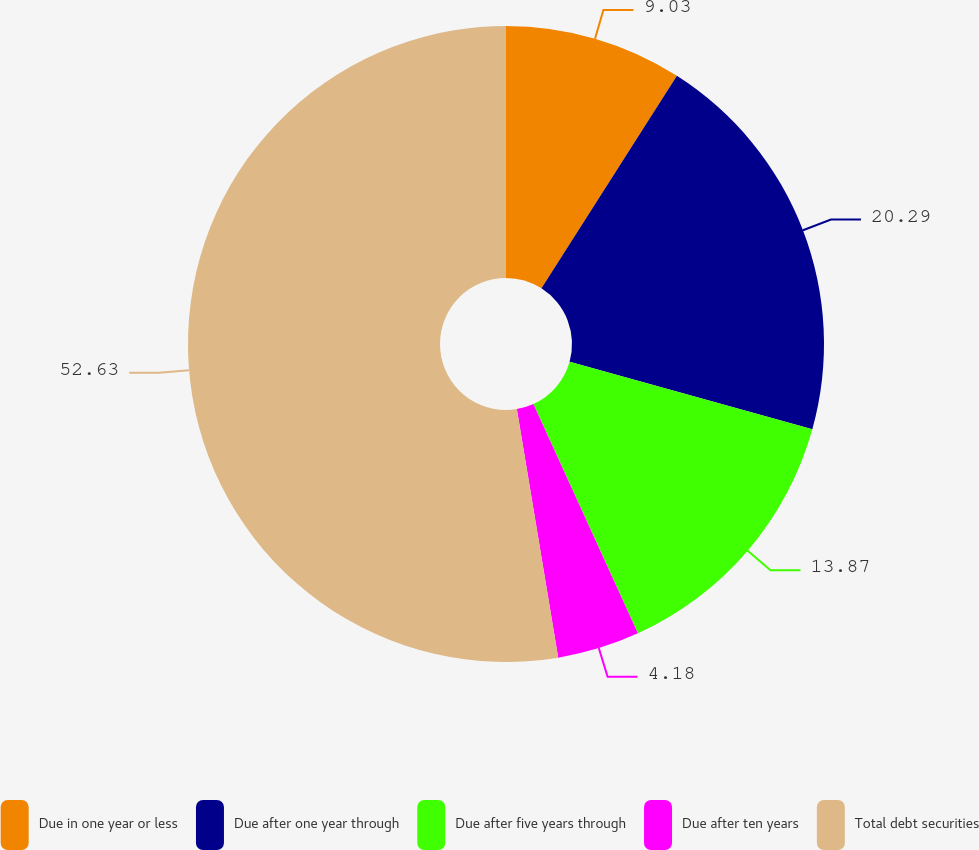<chart> <loc_0><loc_0><loc_500><loc_500><pie_chart><fcel>Due in one year or less<fcel>Due after one year through<fcel>Due after five years through<fcel>Due after ten years<fcel>Total debt securities<nl><fcel>9.03%<fcel>20.29%<fcel>13.87%<fcel>4.18%<fcel>52.62%<nl></chart> 